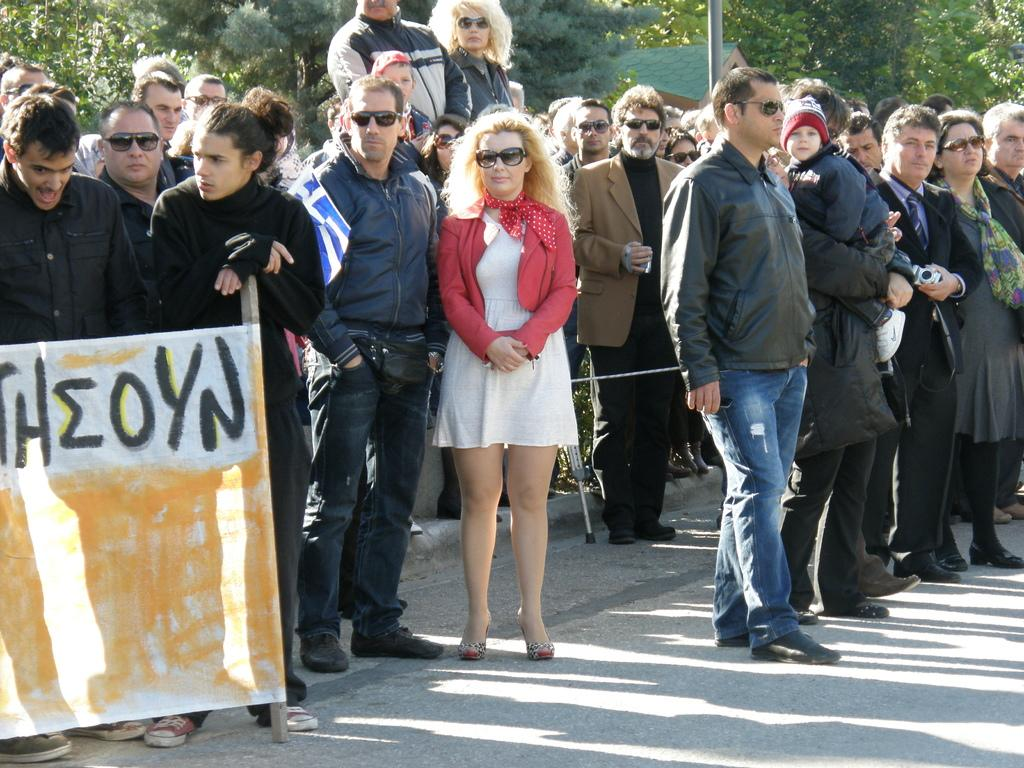How many people are visible in the image? There are many people standing in the image. What are the people wearing? The people are wearing clothes. Are there any specific accessories being worn by some people? Yes, some people are wearing goggles. What type of image is this? The image is a poster. What can be seen on the ground in the image? There is a footpath in the image. What type of natural elements are present in the image? There are trees in the image. Are there any man-made structures visible? Yes, there is a pole and a house in the image. What type of mint can be seen growing near the house in the image? There is no mint present in the image; it only features people, goggles, a poster, footpath, trees, a pole, and a house. 